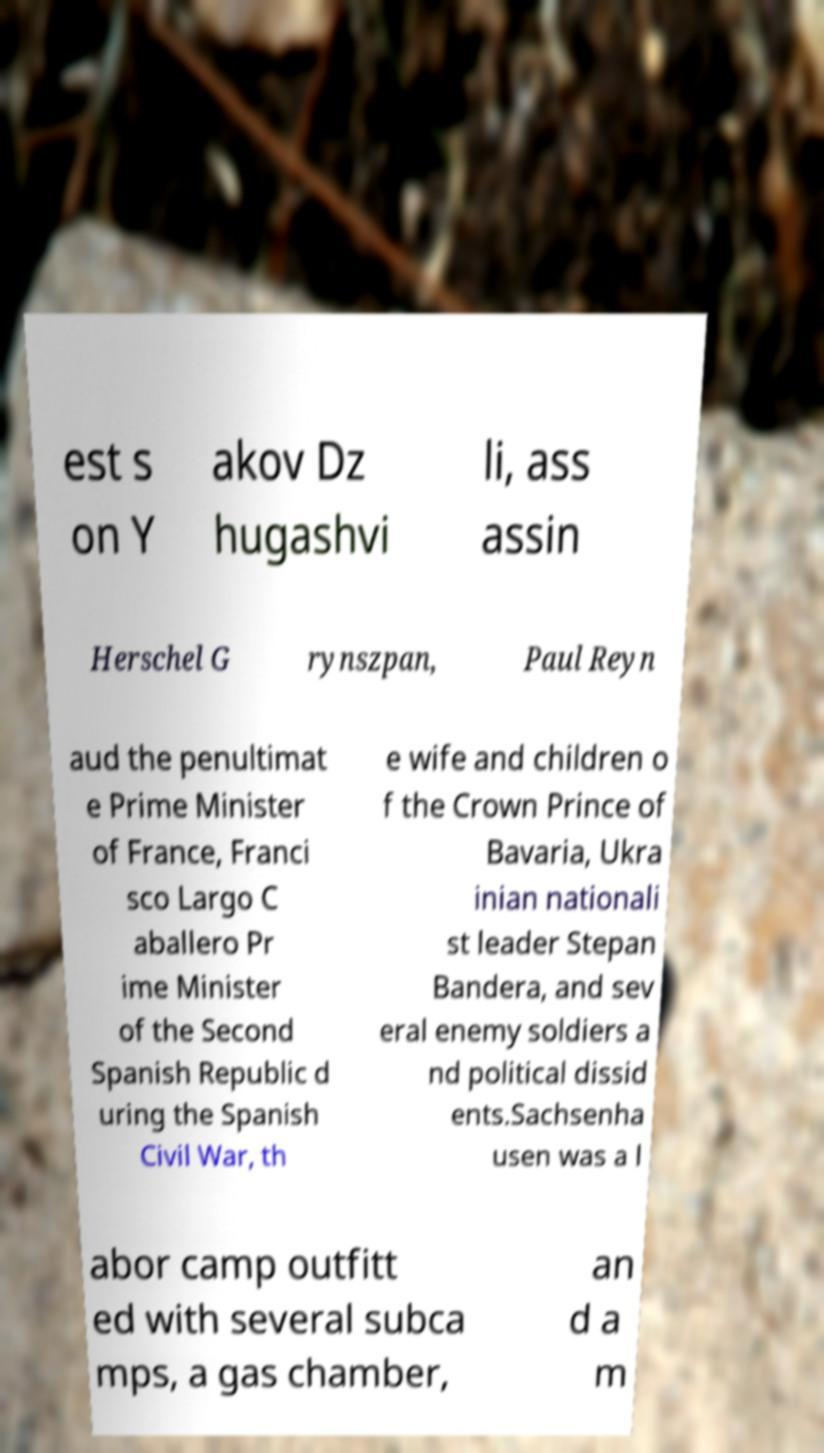I need the written content from this picture converted into text. Can you do that? est s on Y akov Dz hugashvi li, ass assin Herschel G rynszpan, Paul Reyn aud the penultimat e Prime Minister of France, Franci sco Largo C aballero Pr ime Minister of the Second Spanish Republic d uring the Spanish Civil War, th e wife and children o f the Crown Prince of Bavaria, Ukra inian nationali st leader Stepan Bandera, and sev eral enemy soldiers a nd political dissid ents.Sachsenha usen was a l abor camp outfitt ed with several subca mps, a gas chamber, an d a m 